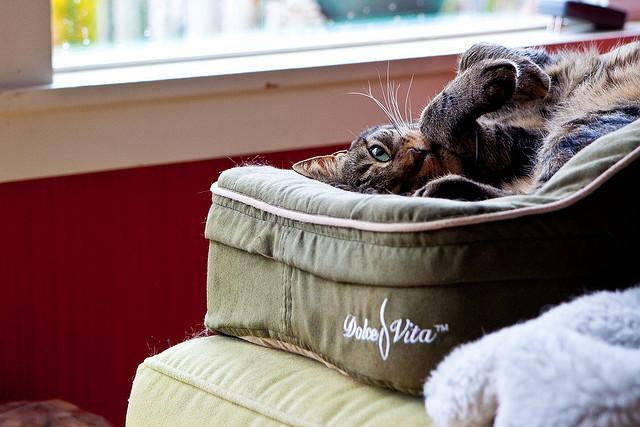What animal is it?
Quick response, please. Cat. Is this a dog bed?
Keep it brief. No. Is the cat scared?
Be succinct. No. 